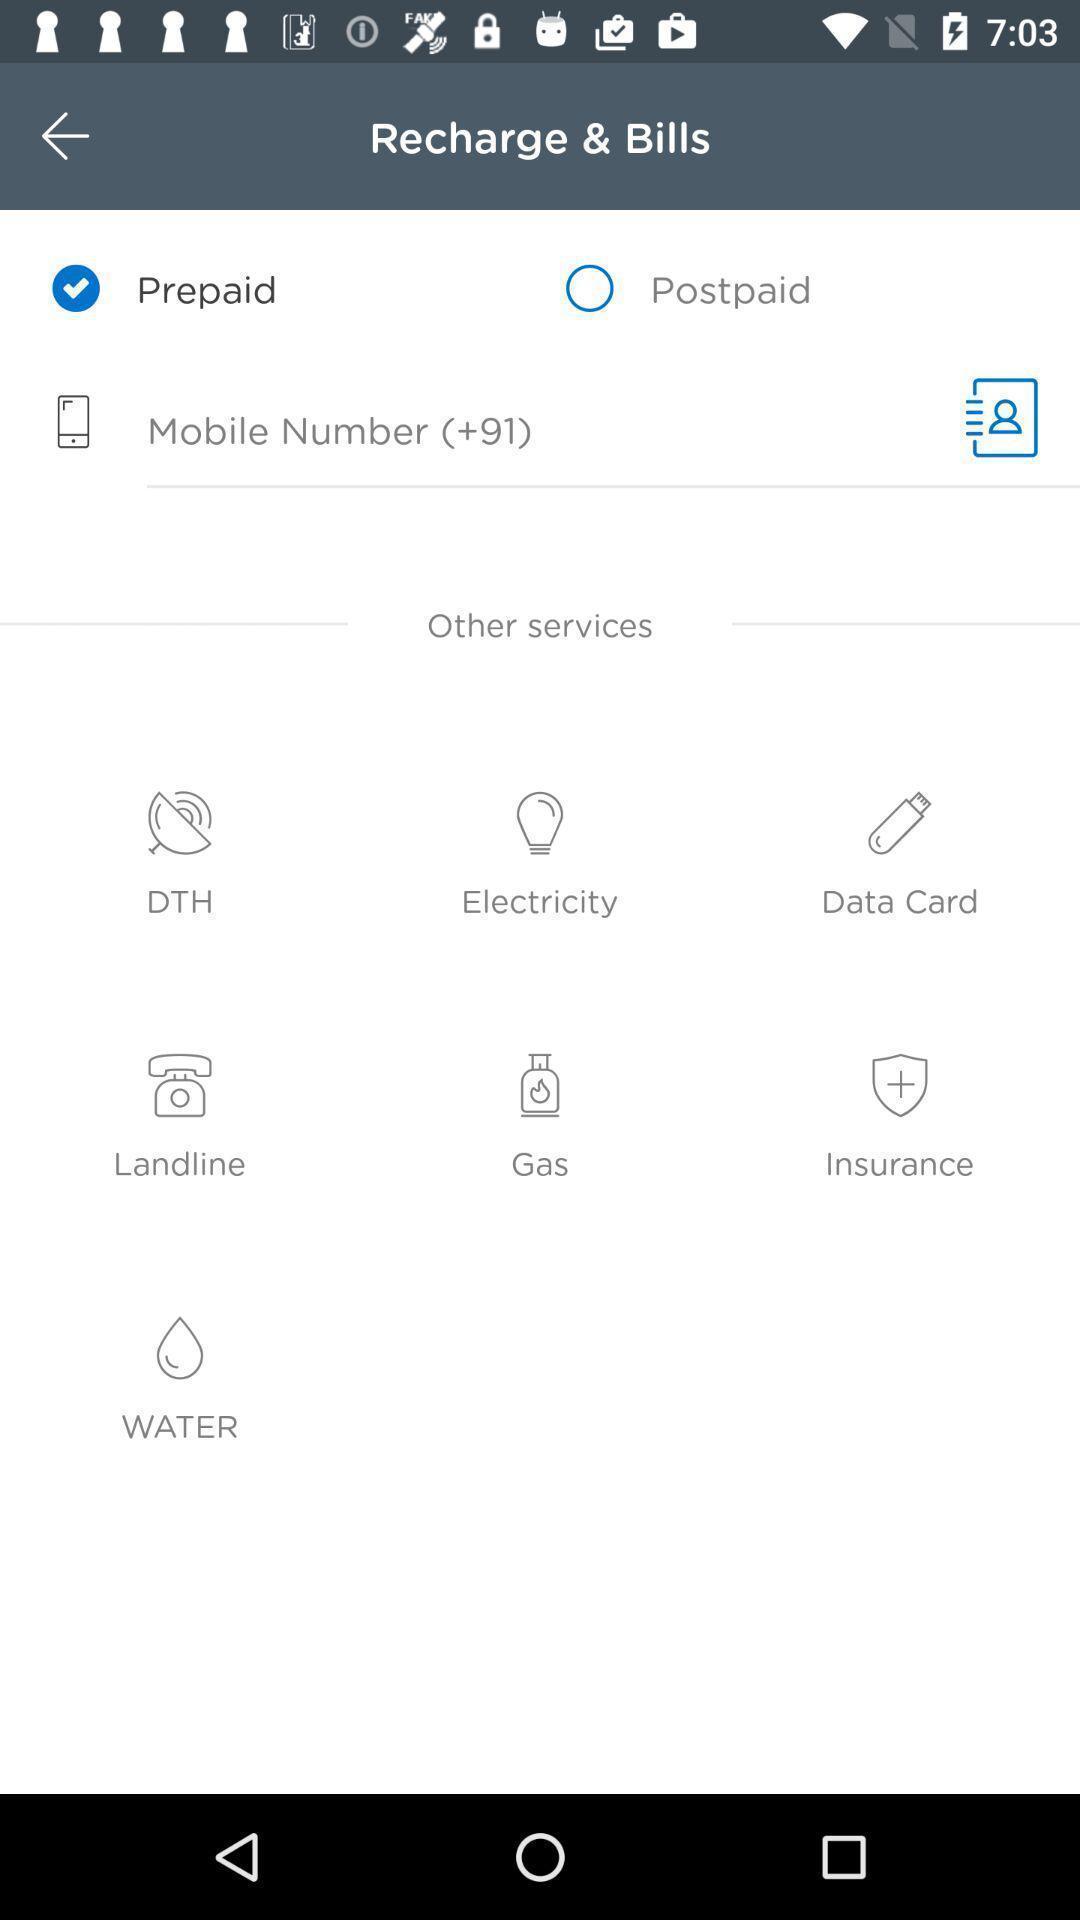What can you discern from this picture? Screen shows about prepaid recharge and bills. 